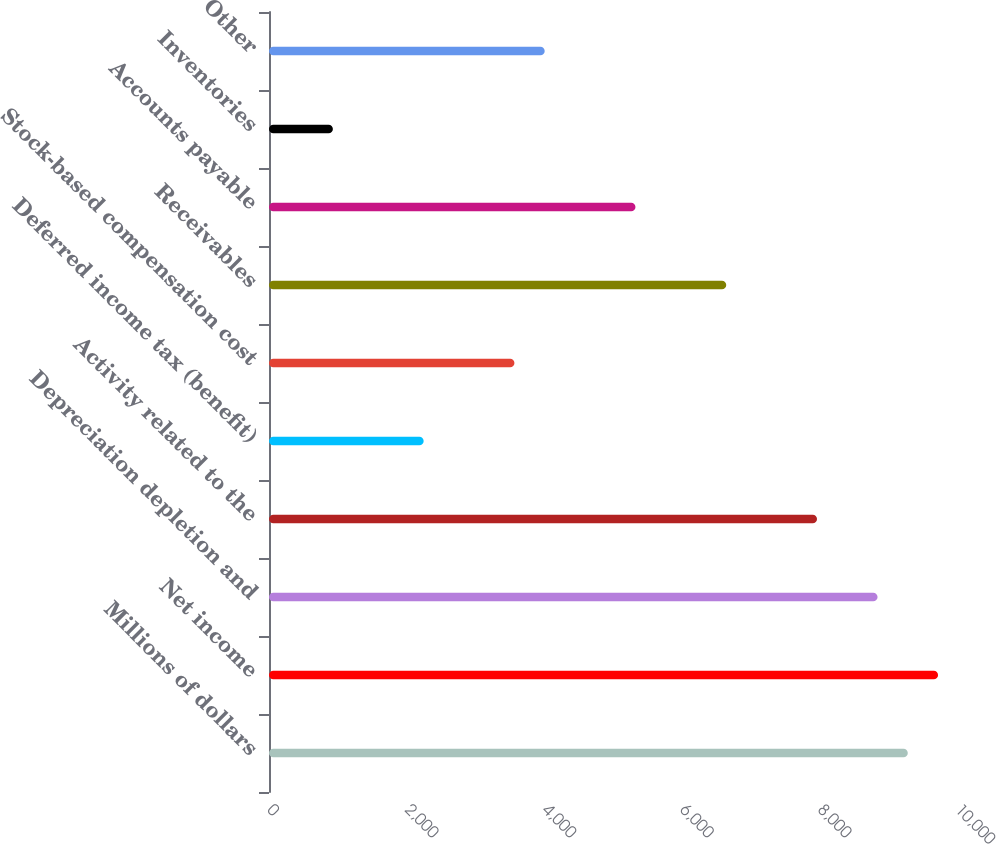<chart> <loc_0><loc_0><loc_500><loc_500><bar_chart><fcel>Millions of dollars<fcel>Net income<fcel>Depreciation depletion and<fcel>Activity related to the<fcel>Deferred income tax (benefit)<fcel>Stock-based compensation cost<fcel>Receivables<fcel>Accounts payable<fcel>Inventories<fcel>Other<nl><fcel>9284.8<fcel>9724.6<fcel>8845<fcel>7965.4<fcel>2248<fcel>3567.4<fcel>6646<fcel>5326.6<fcel>928.6<fcel>4007.2<nl></chart> 